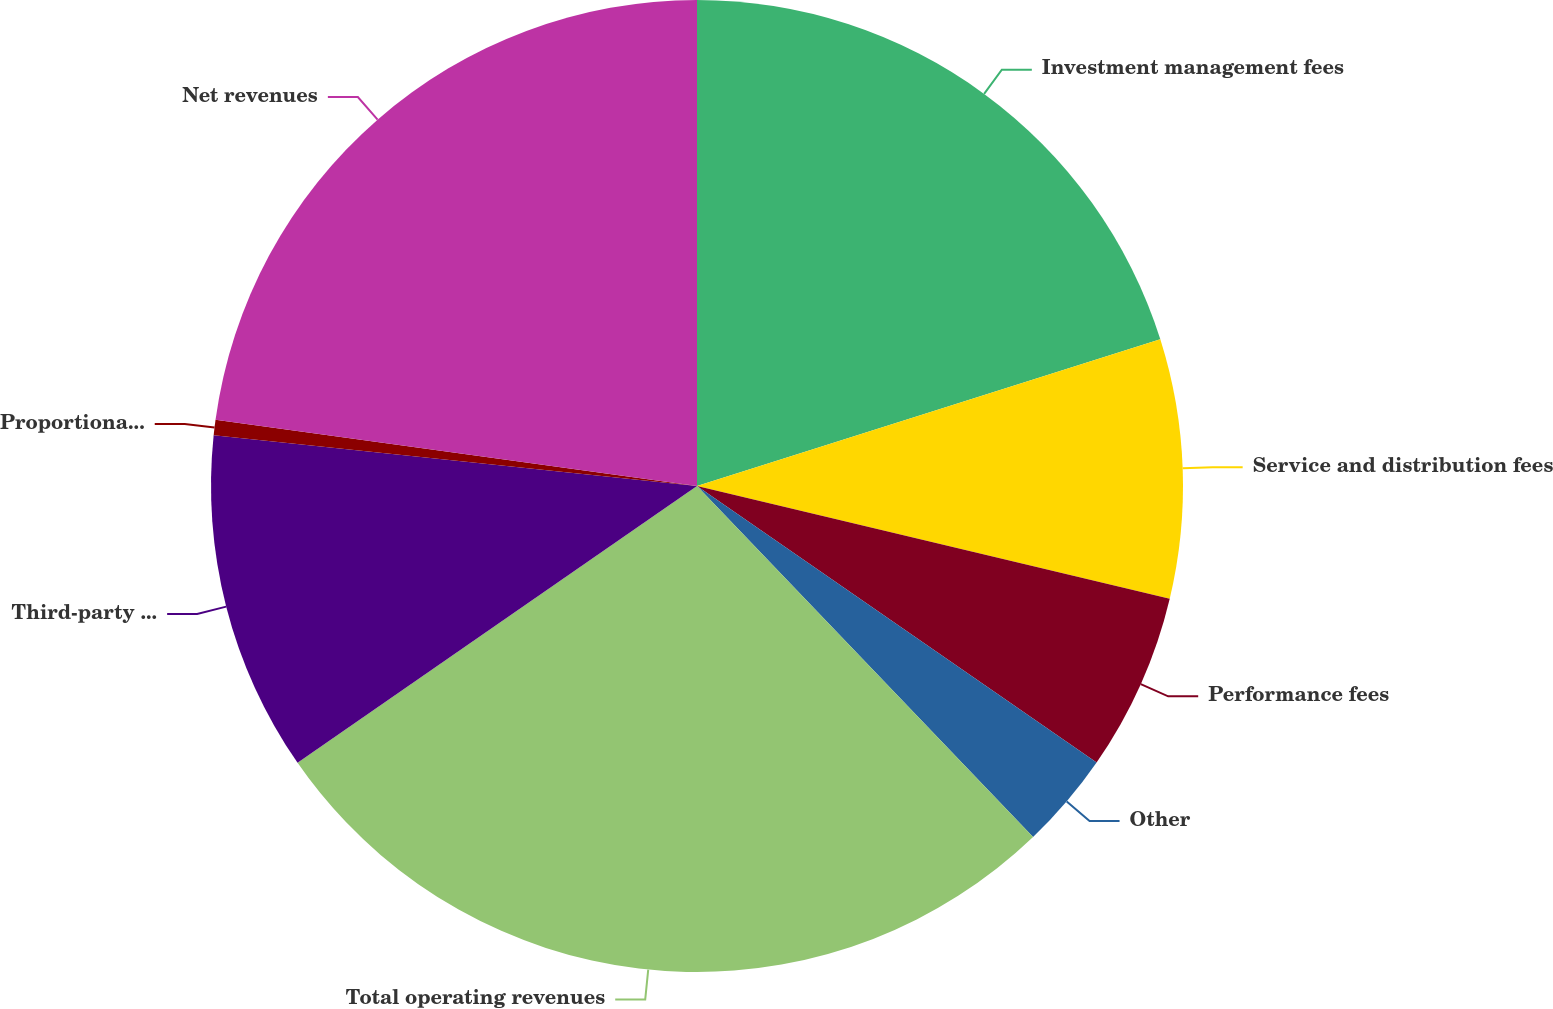Convert chart. <chart><loc_0><loc_0><loc_500><loc_500><pie_chart><fcel>Investment management fees<fcel>Service and distribution fees<fcel>Performance fees<fcel>Other<fcel>Total operating revenues<fcel>Third-party distribution<fcel>Proportional share of revenues<fcel>Net revenues<nl><fcel>20.12%<fcel>8.61%<fcel>5.91%<fcel>3.21%<fcel>27.51%<fcel>11.31%<fcel>0.51%<fcel>22.83%<nl></chart> 